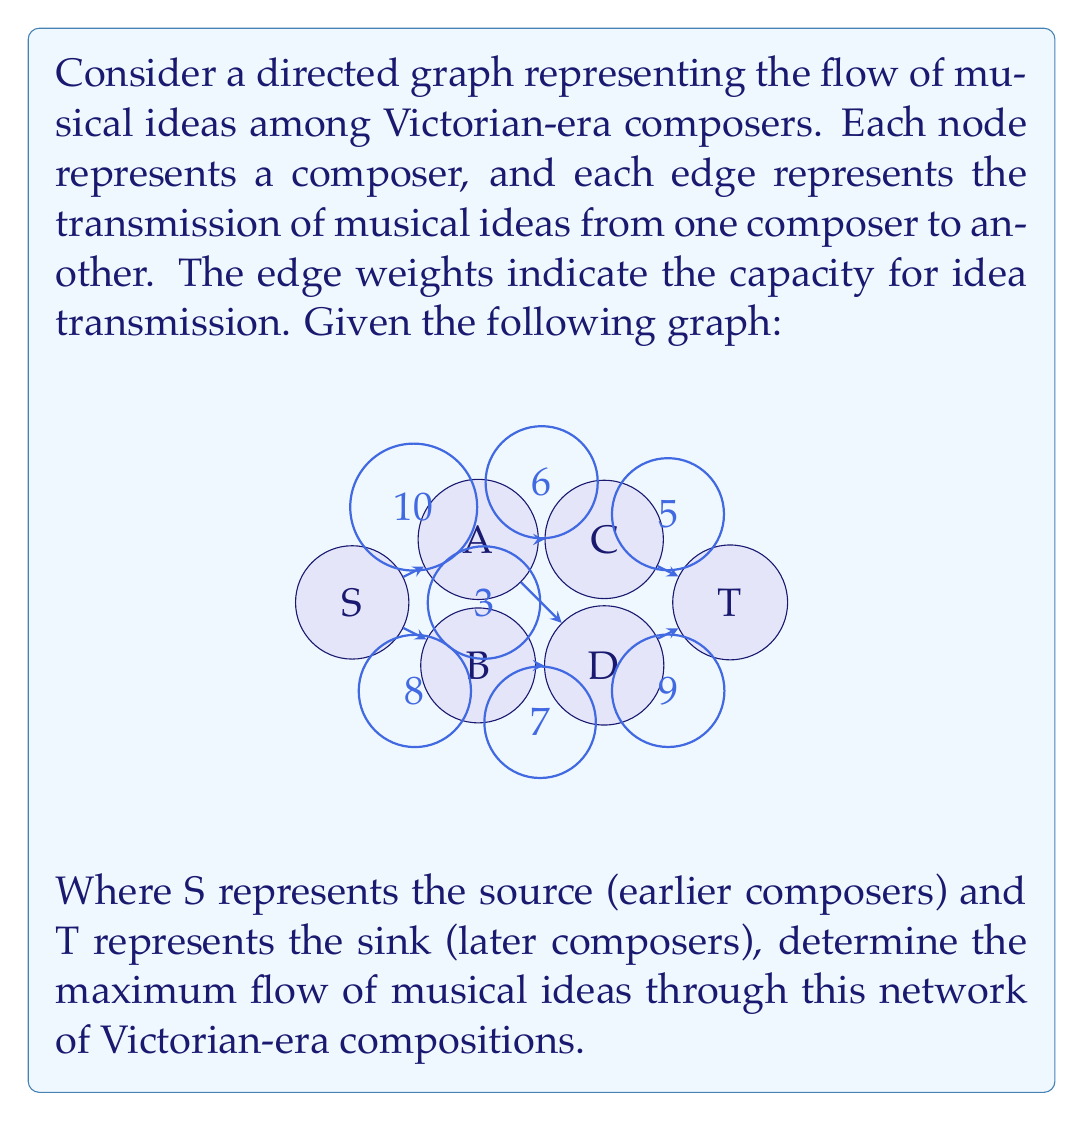Provide a solution to this math problem. To solve this problem, we'll use the Ford-Fulkerson algorithm to find the maximum flow in the given directed graph. The algorithm works as follows:

1. Initialize the flow on all edges to 0.
2. While there exists an augmenting path from source S to sink T:
   a. Find an augmenting path
   b. Determine the bottleneck capacity of the path
   c. Augment the flow along the path by the bottleneck capacity

Let's apply this algorithm step by step:

Iteration 1:
Path: S → A → C → T
Bottleneck: min(10, 6, 5) = 5
Flow: 5

Residual Graph:
S → A: 5/10
A → C: 5/6
C → T: 5/5

Iteration 2:
Path: S → B → D → T
Bottleneck: min(8, 7, 9) = 7
Flow: 5 + 7 = 12

Residual Graph:
S → A: 5/10
S → B: 7/8
A → C: 5/6
B → D: 7/7
C → T: 5/5
D → T: 7/9

Iteration 3:
Path: S → A → D → T
Bottleneck: min(5, 3, 2) = 2
Flow: 12 + 2 = 14

Residual Graph:
S → A: 7/10
S → B: 7/8
A → C: 5/6
A → D: 2/3
B → D: 7/7
C → T: 5/5
D → T: 9/9

At this point, there are no more augmenting paths from S to T, so the algorithm terminates.

The maximum flow is the sum of all flows entering the sink T, which is 5 + 9 = 14.
Answer: The maximum flow of musical ideas through the network of Victorian-era compositions is 14 units. 